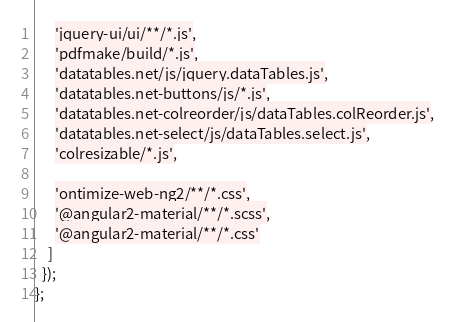Convert code to text. <code><loc_0><loc_0><loc_500><loc_500><_JavaScript_>      'jquery-ui/ui/**/*.js',
      'pdfmake/build/*.js',
      'datatables.net/js/jquery.dataTables.js',
      'datatables.net-buttons/js/*.js',
      'datatables.net-colreorder/js/dataTables.colReorder.js',
      'datatables.net-select/js/dataTables.select.js',
      'colresizable/*.js',

      'ontimize-web-ng2/**/*.css',
      '@angular2-material/**/*.scss',
      '@angular2-material/**/*.css'
    ]
  });
};
</code> 